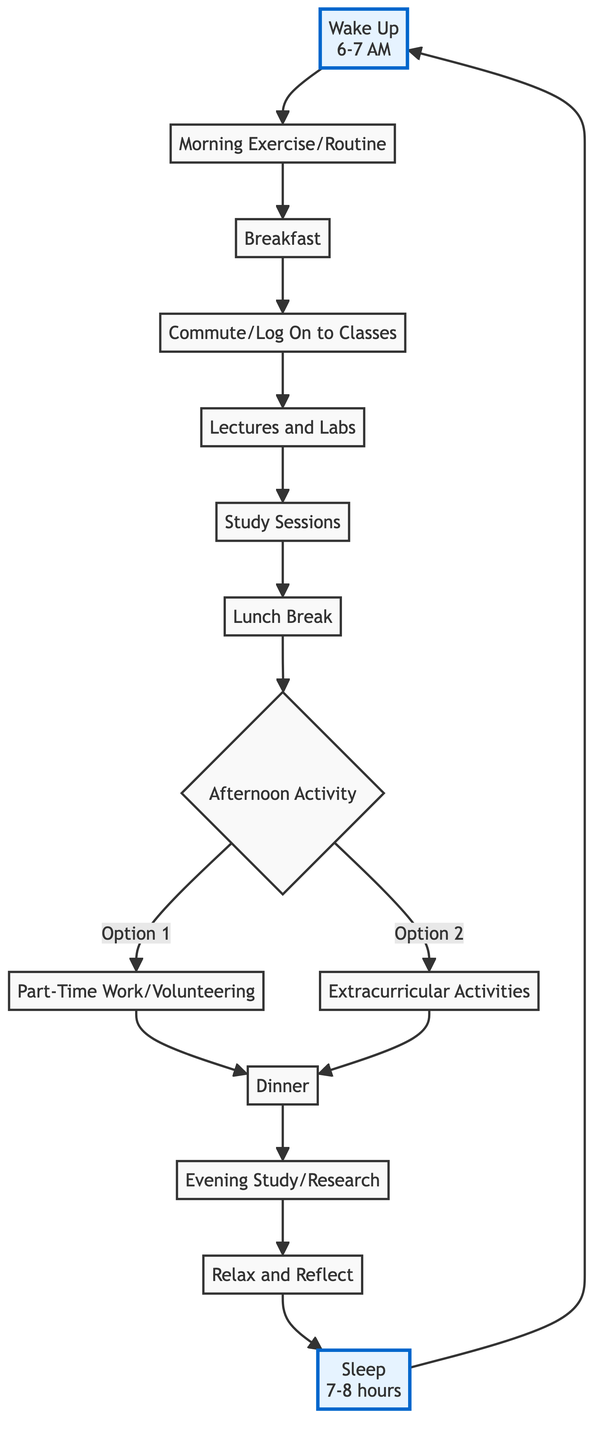What is the first activity in the daily routine? The diagram starts with the node "Wake Up," indicating that waking up is the first activity in the daily routine.
Answer: Wake Up What time does a pre-med student typically wake up? The diagram specifies that a pre-med student usually wakes up around 6-7 AM.
Answer: 6-7 AM How many major activities are there after the morning routine before dinner? From the morning routine ("Morning Exercise/Routine") to dinner, there are five major activities: "Breakfast," "Commute/Log On to Classes," "Lectures and Labs," "Study Sessions," and "Lunch Break." The sequence follows directly.
Answer: 5 What are the two options for afternoon activities? The flowchart presents two options after the lunch break: "Part-Time Work/Volunteering" and "Extracurricular Activities."
Answer: Part-Time Work/Volunteering, Extracurricular Activities What activity does the student do after dinner? Following dinner, the next activity according to the flowchart is "Evening Study/Research."
Answer: Evening Study/Research What is the importance of the "Relax and Reflect" activity? "Relax and Reflect" is positioned before sleep in the diagram, indicating it is a time to wind down and prepare for rest, essential for mental health.
Answer: Wind down What is the last activity before starting the next day? The last activity in the flowchart before the routine starts again is "Sleep," indicating it is essential to get enough rest for the next day.
Answer: Sleep Which activity is directly connected to both "Part-Time Work/Volunteering" and "Extracurricular Activities"? The node "Dinner" is directly connected to both activities, indicating that both path options lead to having dinner afterward.
Answer: Dinner How many hours of sleep does a pre-med student aim to get? The flowchart suggests that a pre-med student aims for 7-8 hours of sleep to maintain health.
Answer: 7-8 hours 